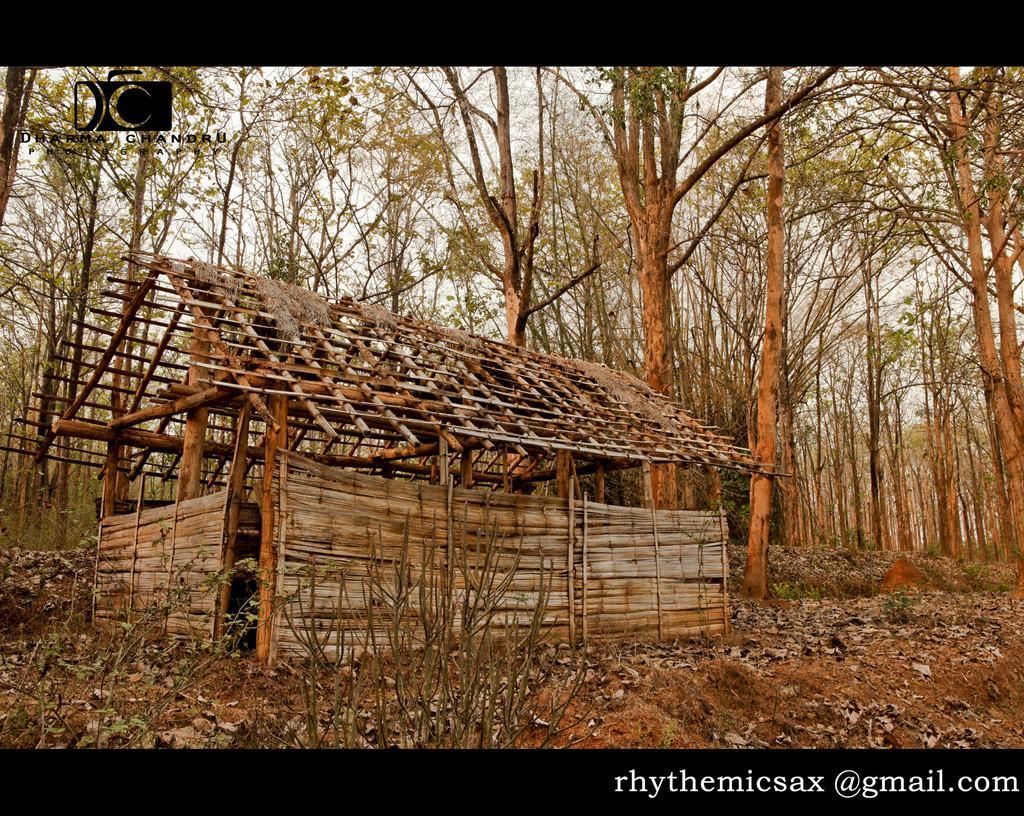Please provide a concise description of this image. In this image I can see the house made up of wooden logs. In the background I can see many trees and the sky. 